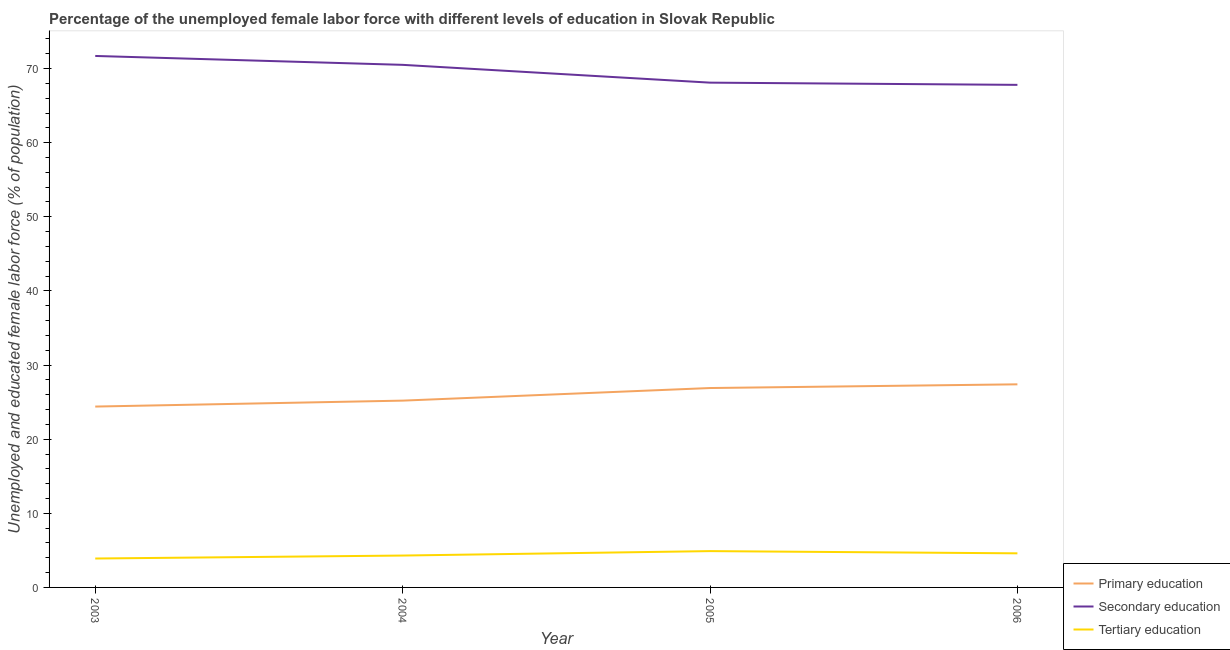How many different coloured lines are there?
Offer a very short reply. 3. What is the percentage of female labor force who received tertiary education in 2004?
Provide a short and direct response. 4.3. Across all years, what is the maximum percentage of female labor force who received secondary education?
Your answer should be very brief. 71.7. Across all years, what is the minimum percentage of female labor force who received tertiary education?
Ensure brevity in your answer.  3.9. In which year was the percentage of female labor force who received primary education maximum?
Your answer should be very brief. 2006. What is the total percentage of female labor force who received secondary education in the graph?
Your answer should be very brief. 278.1. What is the difference between the percentage of female labor force who received primary education in 2003 and that in 2004?
Ensure brevity in your answer.  -0.8. What is the difference between the percentage of female labor force who received secondary education in 2006 and the percentage of female labor force who received tertiary education in 2003?
Make the answer very short. 63.9. What is the average percentage of female labor force who received tertiary education per year?
Your answer should be compact. 4.43. In the year 2004, what is the difference between the percentage of female labor force who received primary education and percentage of female labor force who received secondary education?
Your answer should be very brief. -45.3. What is the ratio of the percentage of female labor force who received secondary education in 2003 to that in 2005?
Offer a terse response. 1.05. Is the percentage of female labor force who received primary education in 2003 less than that in 2004?
Make the answer very short. Yes. Is the difference between the percentage of female labor force who received secondary education in 2004 and 2006 greater than the difference between the percentage of female labor force who received tertiary education in 2004 and 2006?
Provide a short and direct response. Yes. What is the difference between the highest and the lowest percentage of female labor force who received tertiary education?
Keep it short and to the point. 1. In how many years, is the percentage of female labor force who received tertiary education greater than the average percentage of female labor force who received tertiary education taken over all years?
Ensure brevity in your answer.  2. What is the difference between two consecutive major ticks on the Y-axis?
Offer a terse response. 10. Are the values on the major ticks of Y-axis written in scientific E-notation?
Your answer should be compact. No. Does the graph contain any zero values?
Offer a terse response. No. Does the graph contain grids?
Offer a very short reply. No. Where does the legend appear in the graph?
Your response must be concise. Bottom right. How many legend labels are there?
Keep it short and to the point. 3. What is the title of the graph?
Provide a succinct answer. Percentage of the unemployed female labor force with different levels of education in Slovak Republic. What is the label or title of the X-axis?
Keep it short and to the point. Year. What is the label or title of the Y-axis?
Offer a very short reply. Unemployed and educated female labor force (% of population). What is the Unemployed and educated female labor force (% of population) in Primary education in 2003?
Your answer should be very brief. 24.4. What is the Unemployed and educated female labor force (% of population) in Secondary education in 2003?
Offer a terse response. 71.7. What is the Unemployed and educated female labor force (% of population) in Tertiary education in 2003?
Provide a succinct answer. 3.9. What is the Unemployed and educated female labor force (% of population) in Primary education in 2004?
Give a very brief answer. 25.2. What is the Unemployed and educated female labor force (% of population) of Secondary education in 2004?
Keep it short and to the point. 70.5. What is the Unemployed and educated female labor force (% of population) in Tertiary education in 2004?
Keep it short and to the point. 4.3. What is the Unemployed and educated female labor force (% of population) of Primary education in 2005?
Your response must be concise. 26.9. What is the Unemployed and educated female labor force (% of population) in Secondary education in 2005?
Give a very brief answer. 68.1. What is the Unemployed and educated female labor force (% of population) of Tertiary education in 2005?
Your answer should be very brief. 4.9. What is the Unemployed and educated female labor force (% of population) of Primary education in 2006?
Offer a very short reply. 27.4. What is the Unemployed and educated female labor force (% of population) in Secondary education in 2006?
Your answer should be compact. 67.8. What is the Unemployed and educated female labor force (% of population) of Tertiary education in 2006?
Keep it short and to the point. 4.6. Across all years, what is the maximum Unemployed and educated female labor force (% of population) of Primary education?
Your answer should be very brief. 27.4. Across all years, what is the maximum Unemployed and educated female labor force (% of population) of Secondary education?
Give a very brief answer. 71.7. Across all years, what is the maximum Unemployed and educated female labor force (% of population) of Tertiary education?
Provide a succinct answer. 4.9. Across all years, what is the minimum Unemployed and educated female labor force (% of population) of Primary education?
Ensure brevity in your answer.  24.4. Across all years, what is the minimum Unemployed and educated female labor force (% of population) of Secondary education?
Make the answer very short. 67.8. Across all years, what is the minimum Unemployed and educated female labor force (% of population) in Tertiary education?
Your response must be concise. 3.9. What is the total Unemployed and educated female labor force (% of population) of Primary education in the graph?
Offer a very short reply. 103.9. What is the total Unemployed and educated female labor force (% of population) in Secondary education in the graph?
Offer a terse response. 278.1. What is the difference between the Unemployed and educated female labor force (% of population) of Secondary education in 2003 and that in 2004?
Make the answer very short. 1.2. What is the difference between the Unemployed and educated female labor force (% of population) of Tertiary education in 2003 and that in 2004?
Provide a short and direct response. -0.4. What is the difference between the Unemployed and educated female labor force (% of population) of Primary education in 2003 and that in 2005?
Offer a very short reply. -2.5. What is the difference between the Unemployed and educated female labor force (% of population) in Tertiary education in 2003 and that in 2005?
Provide a short and direct response. -1. What is the difference between the Unemployed and educated female labor force (% of population) in Secondary education in 2005 and that in 2006?
Ensure brevity in your answer.  0.3. What is the difference between the Unemployed and educated female labor force (% of population) in Primary education in 2003 and the Unemployed and educated female labor force (% of population) in Secondary education in 2004?
Provide a succinct answer. -46.1. What is the difference between the Unemployed and educated female labor force (% of population) in Primary education in 2003 and the Unemployed and educated female labor force (% of population) in Tertiary education in 2004?
Provide a short and direct response. 20.1. What is the difference between the Unemployed and educated female labor force (% of population) of Secondary education in 2003 and the Unemployed and educated female labor force (% of population) of Tertiary education in 2004?
Make the answer very short. 67.4. What is the difference between the Unemployed and educated female labor force (% of population) of Primary education in 2003 and the Unemployed and educated female labor force (% of population) of Secondary education in 2005?
Offer a terse response. -43.7. What is the difference between the Unemployed and educated female labor force (% of population) in Secondary education in 2003 and the Unemployed and educated female labor force (% of population) in Tertiary education in 2005?
Your answer should be compact. 66.8. What is the difference between the Unemployed and educated female labor force (% of population) in Primary education in 2003 and the Unemployed and educated female labor force (% of population) in Secondary education in 2006?
Keep it short and to the point. -43.4. What is the difference between the Unemployed and educated female labor force (% of population) of Primary education in 2003 and the Unemployed and educated female labor force (% of population) of Tertiary education in 2006?
Keep it short and to the point. 19.8. What is the difference between the Unemployed and educated female labor force (% of population) of Secondary education in 2003 and the Unemployed and educated female labor force (% of population) of Tertiary education in 2006?
Offer a very short reply. 67.1. What is the difference between the Unemployed and educated female labor force (% of population) in Primary education in 2004 and the Unemployed and educated female labor force (% of population) in Secondary education in 2005?
Your response must be concise. -42.9. What is the difference between the Unemployed and educated female labor force (% of population) of Primary education in 2004 and the Unemployed and educated female labor force (% of population) of Tertiary education in 2005?
Your response must be concise. 20.3. What is the difference between the Unemployed and educated female labor force (% of population) of Secondary education in 2004 and the Unemployed and educated female labor force (% of population) of Tertiary education in 2005?
Give a very brief answer. 65.6. What is the difference between the Unemployed and educated female labor force (% of population) in Primary education in 2004 and the Unemployed and educated female labor force (% of population) in Secondary education in 2006?
Ensure brevity in your answer.  -42.6. What is the difference between the Unemployed and educated female labor force (% of population) of Primary education in 2004 and the Unemployed and educated female labor force (% of population) of Tertiary education in 2006?
Offer a very short reply. 20.6. What is the difference between the Unemployed and educated female labor force (% of population) of Secondary education in 2004 and the Unemployed and educated female labor force (% of population) of Tertiary education in 2006?
Offer a terse response. 65.9. What is the difference between the Unemployed and educated female labor force (% of population) in Primary education in 2005 and the Unemployed and educated female labor force (% of population) in Secondary education in 2006?
Your response must be concise. -40.9. What is the difference between the Unemployed and educated female labor force (% of population) in Primary education in 2005 and the Unemployed and educated female labor force (% of population) in Tertiary education in 2006?
Give a very brief answer. 22.3. What is the difference between the Unemployed and educated female labor force (% of population) of Secondary education in 2005 and the Unemployed and educated female labor force (% of population) of Tertiary education in 2006?
Keep it short and to the point. 63.5. What is the average Unemployed and educated female labor force (% of population) in Primary education per year?
Keep it short and to the point. 25.98. What is the average Unemployed and educated female labor force (% of population) of Secondary education per year?
Make the answer very short. 69.53. What is the average Unemployed and educated female labor force (% of population) of Tertiary education per year?
Your response must be concise. 4.42. In the year 2003, what is the difference between the Unemployed and educated female labor force (% of population) of Primary education and Unemployed and educated female labor force (% of population) of Secondary education?
Ensure brevity in your answer.  -47.3. In the year 2003, what is the difference between the Unemployed and educated female labor force (% of population) of Primary education and Unemployed and educated female labor force (% of population) of Tertiary education?
Offer a terse response. 20.5. In the year 2003, what is the difference between the Unemployed and educated female labor force (% of population) in Secondary education and Unemployed and educated female labor force (% of population) in Tertiary education?
Make the answer very short. 67.8. In the year 2004, what is the difference between the Unemployed and educated female labor force (% of population) of Primary education and Unemployed and educated female labor force (% of population) of Secondary education?
Offer a very short reply. -45.3. In the year 2004, what is the difference between the Unemployed and educated female labor force (% of population) of Primary education and Unemployed and educated female labor force (% of population) of Tertiary education?
Give a very brief answer. 20.9. In the year 2004, what is the difference between the Unemployed and educated female labor force (% of population) of Secondary education and Unemployed and educated female labor force (% of population) of Tertiary education?
Your answer should be very brief. 66.2. In the year 2005, what is the difference between the Unemployed and educated female labor force (% of population) of Primary education and Unemployed and educated female labor force (% of population) of Secondary education?
Offer a very short reply. -41.2. In the year 2005, what is the difference between the Unemployed and educated female labor force (% of population) in Primary education and Unemployed and educated female labor force (% of population) in Tertiary education?
Keep it short and to the point. 22. In the year 2005, what is the difference between the Unemployed and educated female labor force (% of population) of Secondary education and Unemployed and educated female labor force (% of population) of Tertiary education?
Give a very brief answer. 63.2. In the year 2006, what is the difference between the Unemployed and educated female labor force (% of population) of Primary education and Unemployed and educated female labor force (% of population) of Secondary education?
Your answer should be very brief. -40.4. In the year 2006, what is the difference between the Unemployed and educated female labor force (% of population) of Primary education and Unemployed and educated female labor force (% of population) of Tertiary education?
Offer a very short reply. 22.8. In the year 2006, what is the difference between the Unemployed and educated female labor force (% of population) of Secondary education and Unemployed and educated female labor force (% of population) of Tertiary education?
Provide a short and direct response. 63.2. What is the ratio of the Unemployed and educated female labor force (% of population) in Primary education in 2003 to that in 2004?
Your answer should be compact. 0.97. What is the ratio of the Unemployed and educated female labor force (% of population) of Tertiary education in 2003 to that in 2004?
Ensure brevity in your answer.  0.91. What is the ratio of the Unemployed and educated female labor force (% of population) in Primary education in 2003 to that in 2005?
Give a very brief answer. 0.91. What is the ratio of the Unemployed and educated female labor force (% of population) in Secondary education in 2003 to that in 2005?
Make the answer very short. 1.05. What is the ratio of the Unemployed and educated female labor force (% of population) of Tertiary education in 2003 to that in 2005?
Offer a very short reply. 0.8. What is the ratio of the Unemployed and educated female labor force (% of population) of Primary education in 2003 to that in 2006?
Give a very brief answer. 0.89. What is the ratio of the Unemployed and educated female labor force (% of population) in Secondary education in 2003 to that in 2006?
Your answer should be compact. 1.06. What is the ratio of the Unemployed and educated female labor force (% of population) in Tertiary education in 2003 to that in 2006?
Offer a terse response. 0.85. What is the ratio of the Unemployed and educated female labor force (% of population) of Primary education in 2004 to that in 2005?
Offer a terse response. 0.94. What is the ratio of the Unemployed and educated female labor force (% of population) in Secondary education in 2004 to that in 2005?
Your response must be concise. 1.04. What is the ratio of the Unemployed and educated female labor force (% of population) in Tertiary education in 2004 to that in 2005?
Provide a short and direct response. 0.88. What is the ratio of the Unemployed and educated female labor force (% of population) in Primary education in 2004 to that in 2006?
Provide a short and direct response. 0.92. What is the ratio of the Unemployed and educated female labor force (% of population) of Secondary education in 2004 to that in 2006?
Your response must be concise. 1.04. What is the ratio of the Unemployed and educated female labor force (% of population) of Tertiary education in 2004 to that in 2006?
Provide a short and direct response. 0.93. What is the ratio of the Unemployed and educated female labor force (% of population) of Primary education in 2005 to that in 2006?
Offer a terse response. 0.98. What is the ratio of the Unemployed and educated female labor force (% of population) in Tertiary education in 2005 to that in 2006?
Ensure brevity in your answer.  1.07. What is the difference between the highest and the second highest Unemployed and educated female labor force (% of population) of Tertiary education?
Your answer should be compact. 0.3. What is the difference between the highest and the lowest Unemployed and educated female labor force (% of population) in Primary education?
Make the answer very short. 3. What is the difference between the highest and the lowest Unemployed and educated female labor force (% of population) of Secondary education?
Your response must be concise. 3.9. What is the difference between the highest and the lowest Unemployed and educated female labor force (% of population) of Tertiary education?
Offer a very short reply. 1. 